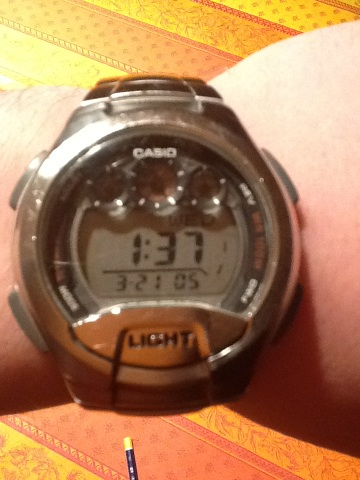How can you tell the watch is well-used? The watch appears to have some wear on the strap and bezel, indicating it has been used quite a bit. The surface scratches and the slightly faded finish suggest it's been worn during various activities over time. 